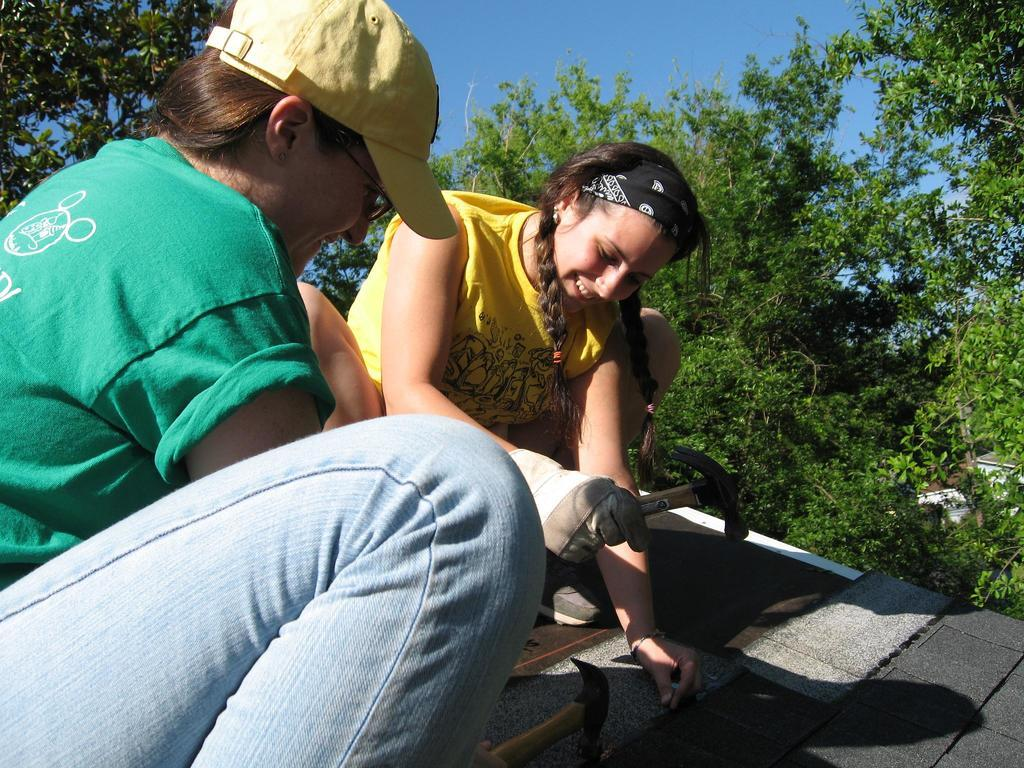How many women are in the foreground of the picture? There are two women in the foreground of the picture. What are the women holding in their hands? The women are holding hammers. What activity are the women engaged in? The women are doing wooden work. What can be seen in the center of the picture? There are trees in the center of the picture. How would you describe the weather based on the image? The sky is sunny, suggesting a clear and bright day. How many tickets are visible in the image? There are no tickets present in the image. What type of feast is being prepared by the women in the image? There is no feast being prepared in the image; the women are doing wooden work with hammers. 